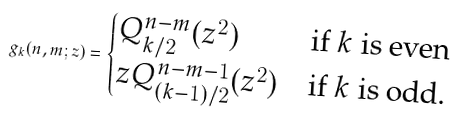Convert formula to latex. <formula><loc_0><loc_0><loc_500><loc_500>g _ { k } ( n , m ; z ) = \begin{cases} Q ^ { n - m } _ { k / 2 } ( z ^ { 2 } ) & \text {if $k$ is even} \\ z Q ^ { n - m - 1 } _ { ( k - 1 ) / 2 } ( z ^ { 2 } ) & \text {if $k$ is odd.} \end{cases}</formula> 